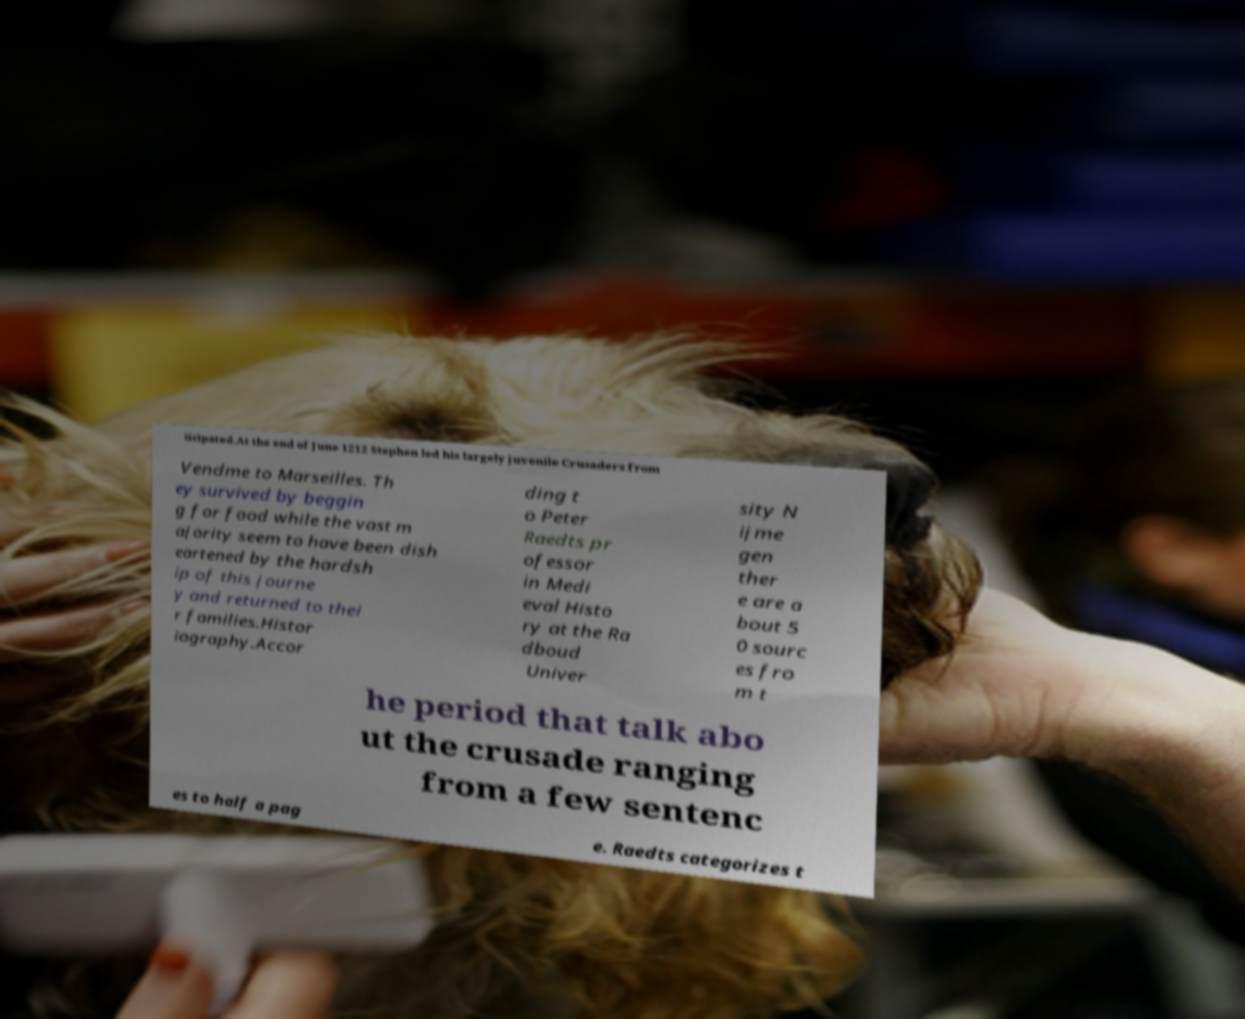There's text embedded in this image that I need extracted. Can you transcribe it verbatim? ticipated.At the end of June 1212 Stephen led his largely juvenile Crusaders from Vendme to Marseilles. Th ey survived by beggin g for food while the vast m ajority seem to have been dish eartened by the hardsh ip of this journe y and returned to thei r families.Histor iography.Accor ding t o Peter Raedts pr ofessor in Medi eval Histo ry at the Ra dboud Univer sity N ijme gen ther e are a bout 5 0 sourc es fro m t he period that talk abo ut the crusade ranging from a few sentenc es to half a pag e. Raedts categorizes t 